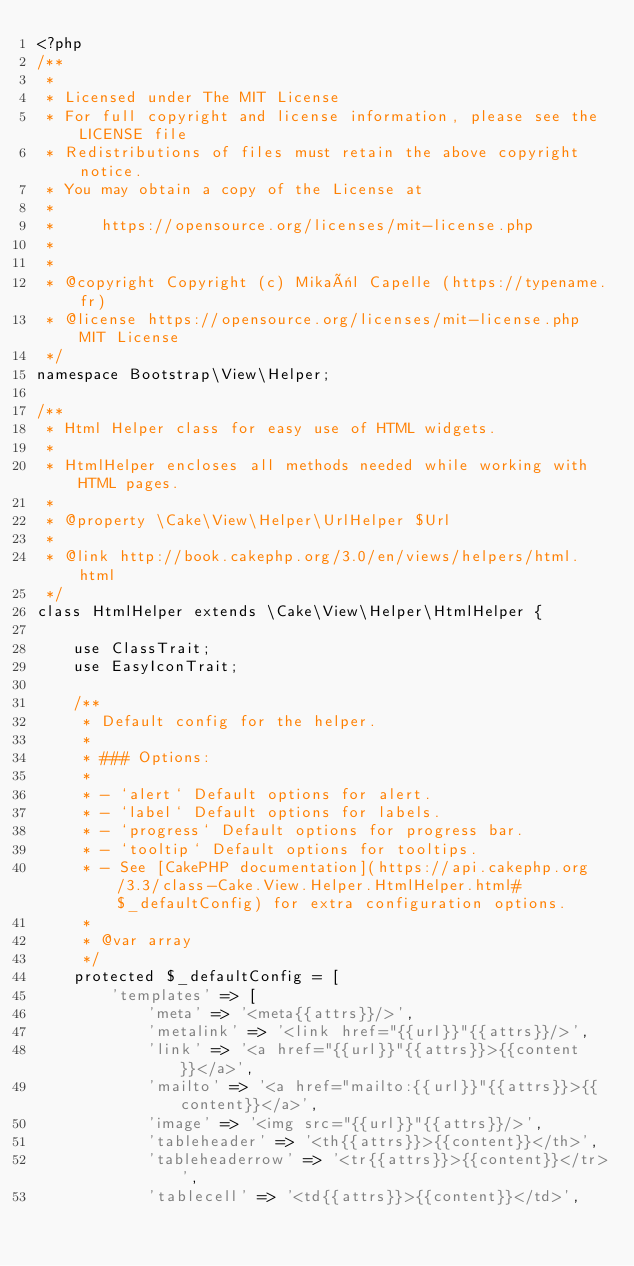Convert code to text. <code><loc_0><loc_0><loc_500><loc_500><_PHP_><?php
/**
 *
 * Licensed under The MIT License
 * For full copyright and license information, please see the LICENSE file
 * Redistributions of files must retain the above copyright notice.
 * You may obtain a copy of the License at
 *
 *     https://opensource.org/licenses/mit-license.php
 *
 *
 * @copyright Copyright (c) Mikaël Capelle (https://typename.fr)
 * @license https://opensource.org/licenses/mit-license.php MIT License
 */
namespace Bootstrap\View\Helper;

/**
 * Html Helper class for easy use of HTML widgets.
 *
 * HtmlHelper encloses all methods needed while working with HTML pages.
 *
 * @property \Cake\View\Helper\UrlHelper $Url
 *
 * @link http://book.cakephp.org/3.0/en/views/helpers/html.html
 */
class HtmlHelper extends \Cake\View\Helper\HtmlHelper {

    use ClassTrait;
    use EasyIconTrait;

    /**
     * Default config for the helper.
     *
     * ### Options:
     *
     * - `alert` Default options for alert.
     * - `label` Default options for labels.
     * - `progress` Default options for progress bar.
     * - `tooltip` Default options for tooltips.
     * - See [CakePHP documentation](https://api.cakephp.org/3.3/class-Cake.View.Helper.HtmlHelper.html#$_defaultConfig) for extra configuration options.
     *
     * @var array
     */
    protected $_defaultConfig = [
        'templates' => [
            'meta' => '<meta{{attrs}}/>',
            'metalink' => '<link href="{{url}}"{{attrs}}/>',
            'link' => '<a href="{{url}}"{{attrs}}>{{content}}</a>',
            'mailto' => '<a href="mailto:{{url}}"{{attrs}}>{{content}}</a>',
            'image' => '<img src="{{url}}"{{attrs}}/>',
            'tableheader' => '<th{{attrs}}>{{content}}</th>',
            'tableheaderrow' => '<tr{{attrs}}>{{content}}</tr>',
            'tablecell' => '<td{{attrs}}>{{content}}</td>',</code> 